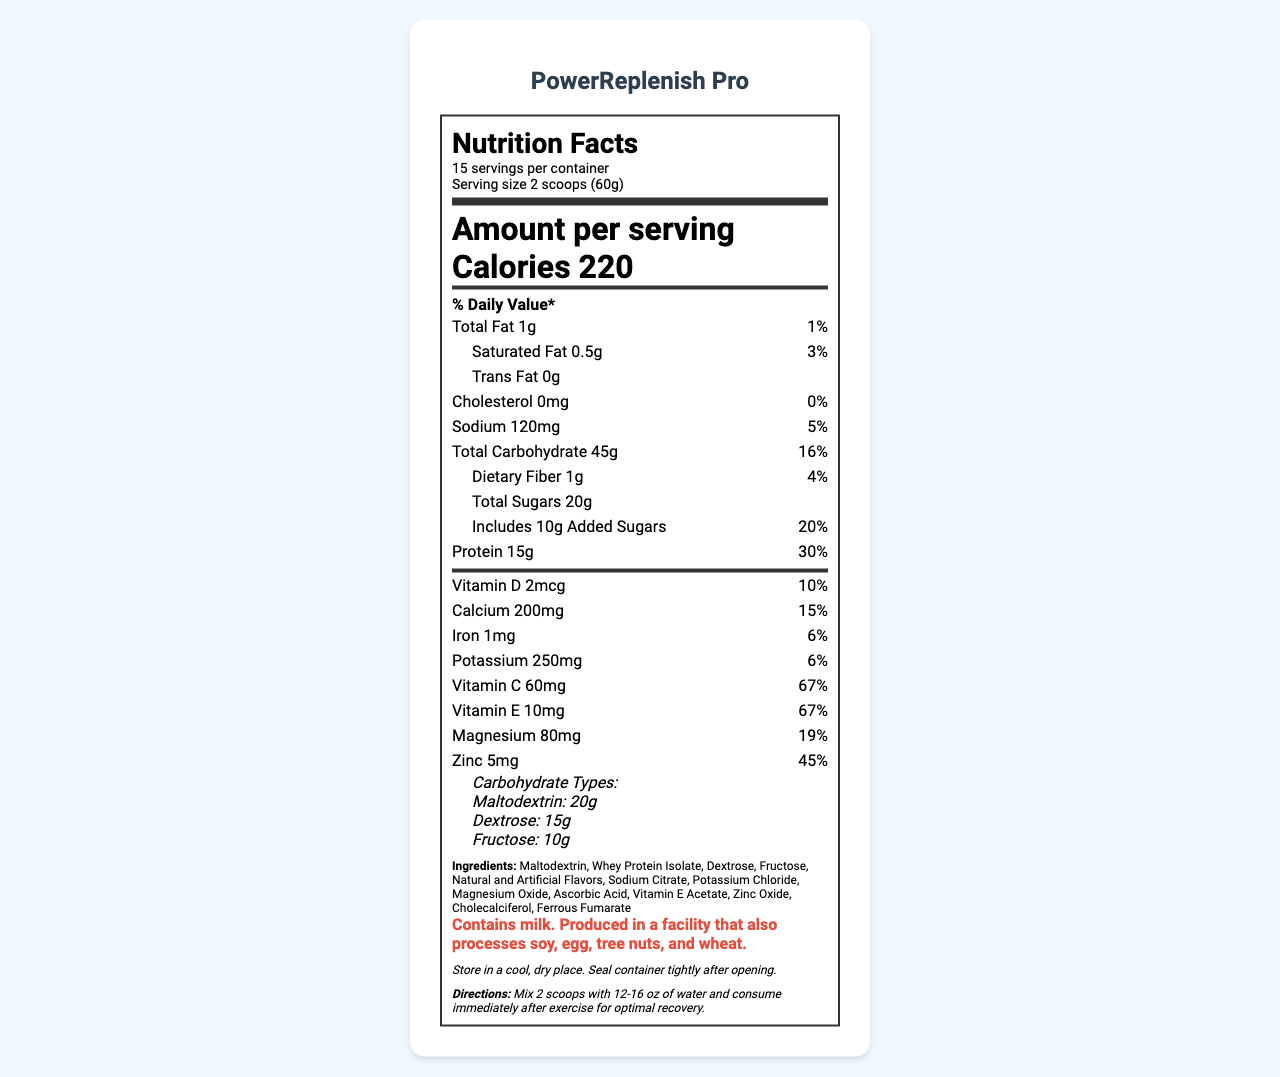what is the serving size? The serving size is clearly listed under the nutrition header.
Answer: 2 scoops (60g) how many calories are in each serving? It is mentioned in large font under the "Amount per serving" section.
Answer: 220 how much dietary fiber does one serving contain? It is mentioned in the "Total Carbohydrate" section under dietary fiber.
Answer: 1g which vitamins have the highest daily value in one serving? These values are listed in the vitamins and minerals section and are both at 67%.
Answer: Vitamin C (67%) and Vitamin E (67%) what are the types of carbohydrates in this product? The carbohydrate types are listed under the "Carbohydrate Types" section.
Answer: Maltodextrin, Dextrose, Fructose how much protein does one serving provide? This information is found under the nutrient section for protein.
Answer: 15g how many servings are in one container? It is mentioned in the serving info section under the nutrition header.
Answer: 15 how much total fat is in one serving? A. 1g B. 2g C. 3g D. 4g The total fat amount is listed under the nutrient section as "Total Fat 1g."
Answer: A. 1g which ingredient is listed first in the ingredients list? A. Dextrose B. Whey Protein Isolate C. Maltodextrin Ingredients are usually listed by weight, and Maltodextrin is the first ingredient listed.
Answer: C. Maltodextrin how much calcium is in one serving? A. 100mg B. 150mg C. 200mg D. 250mg The amount of calcium is listed under the vitamins and minerals section as "Calcium 200mg."
Answer: C. 200mg does the product contain any allergens? This is mentioned in the allergen information section.
Answer: Yes, it contains milk is there any trans fat in the product? The "Trans Fat" section explicitly states "0g."
Answer: No can the exact formula of the ingredients be determined from this document? The document lists the ingredients, but not their exact quantities (except for specific carbs) or formulation details.
Answer: Cannot be determined what is the main idea of the document? The document mainly covers nutrition facts, carbohydrate types, added vitamins and minerals, and other relevant product details.
Answer: The document provides detailed nutritional information, ingredient list, and usage directions for the PowerReplenish Pro post-workout recovery supplement. what is the percentage of daily value for magnesium? This percentage is listed under the vitamins and minerals section as "Magnesium 80mg (19%)."
Answer: 19% what should you do after opening the container? This information is found in the storage instructions section.
Answer: Seal container tightly and store in a cool, dry place. 